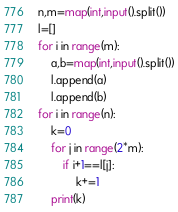Convert code to text. <code><loc_0><loc_0><loc_500><loc_500><_Python_>n,m=map(int,input().split())
l=[]
for i in range(m):
    a,b=map(int,input().split())
    l.append(a)
    l.append(b)
for i in range(n):
    k=0
    for j in range(2*m):
        if i+1==l[j]:
            k+=1
    print(k)
</code> 